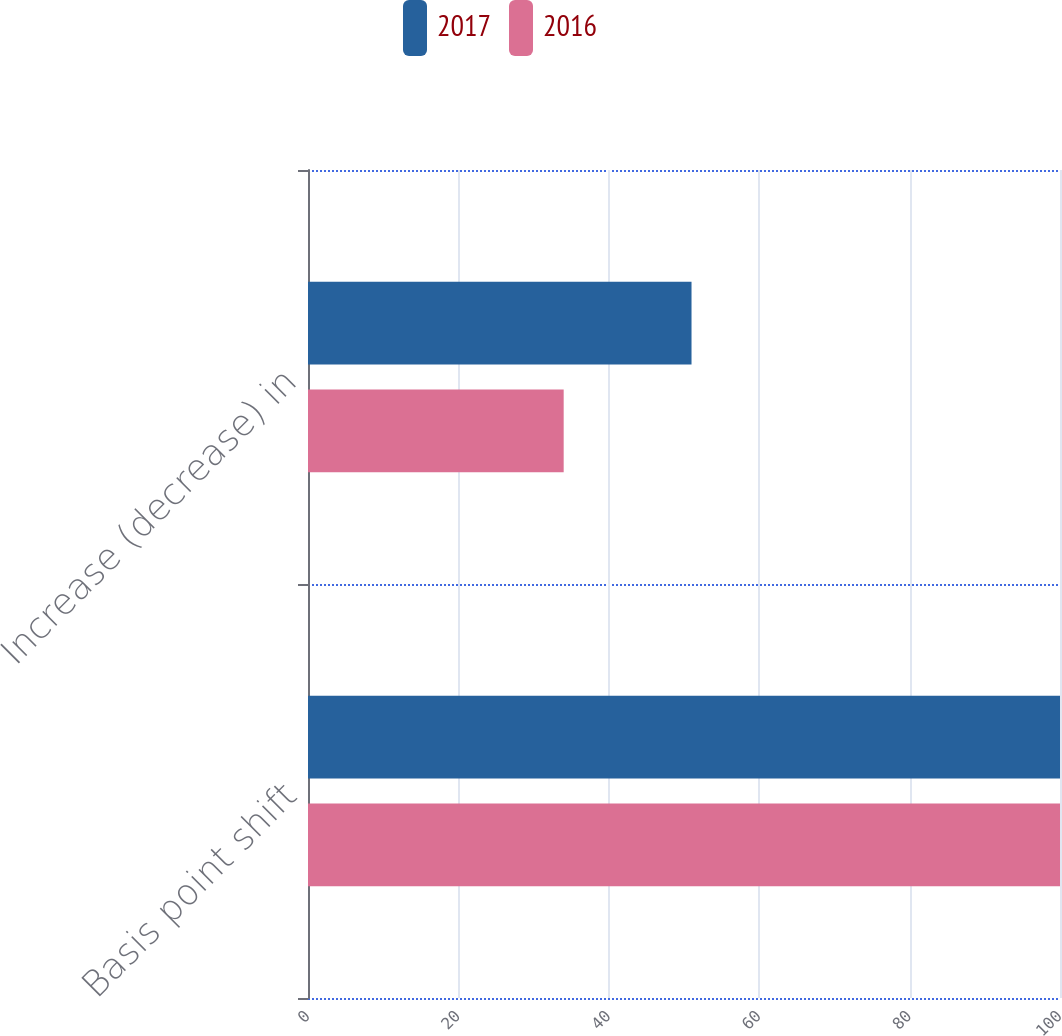Convert chart. <chart><loc_0><loc_0><loc_500><loc_500><stacked_bar_chart><ecel><fcel>Basis point shift<fcel>Increase (decrease) in<nl><fcel>2017<fcel>100<fcel>51<nl><fcel>2016<fcel>100<fcel>34<nl></chart> 